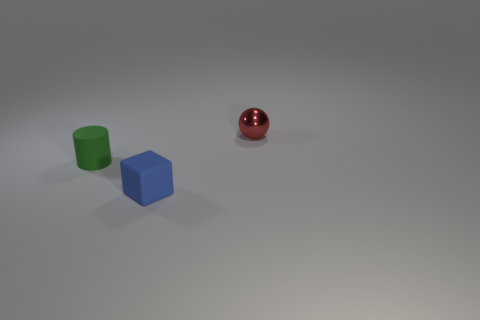What size is the thing that is behind the blue rubber object and to the left of the shiny object?
Your answer should be compact. Small. How many other objects are the same shape as the blue thing?
Offer a terse response. 0. How many cylinders are tiny metallic things or blue rubber objects?
Give a very brief answer. 0. Are there any shiny spheres that are to the right of the tiny rubber thing behind the rubber object to the right of the green rubber cylinder?
Your response must be concise. Yes. How many brown things are cylinders or balls?
Provide a short and direct response. 0. What is the material of the thing right of the object that is in front of the tiny green cylinder?
Make the answer very short. Metal. Does the tiny blue thing have the same shape as the green thing?
Your response must be concise. No. The matte block that is the same size as the metal object is what color?
Your answer should be very brief. Blue. Are there any small rubber spheres of the same color as the rubber block?
Ensure brevity in your answer.  No. Are any red metal spheres visible?
Your response must be concise. Yes. 